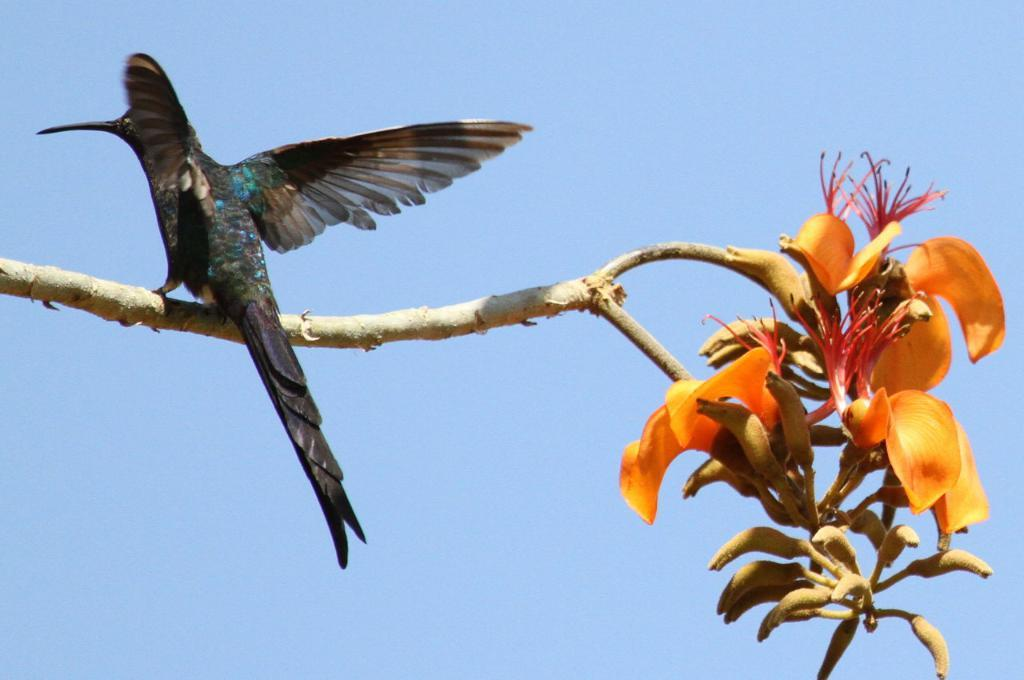What type of animal can be seen in the image? There is a bird in the image. Where is the bird located? The bird is on the branch of a tree. What other elements can be seen in the image? There are flowers and buds in the image. What part of the natural environment is visible in the image? The sky is visible in the image. What type of texture can be seen on the bird's leg in the image? There is no information about the bird's leg or its texture in the image. Is there a swing visible in the image? No, there is no swing present in the image. 